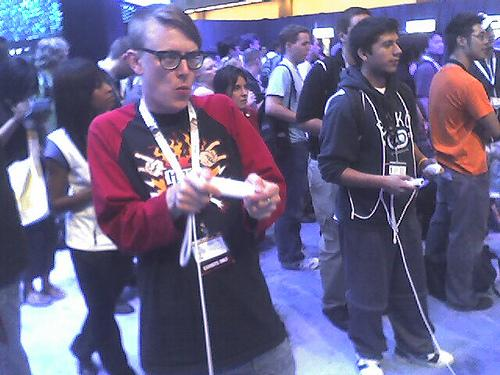What are the people in the front holding? game controllers 